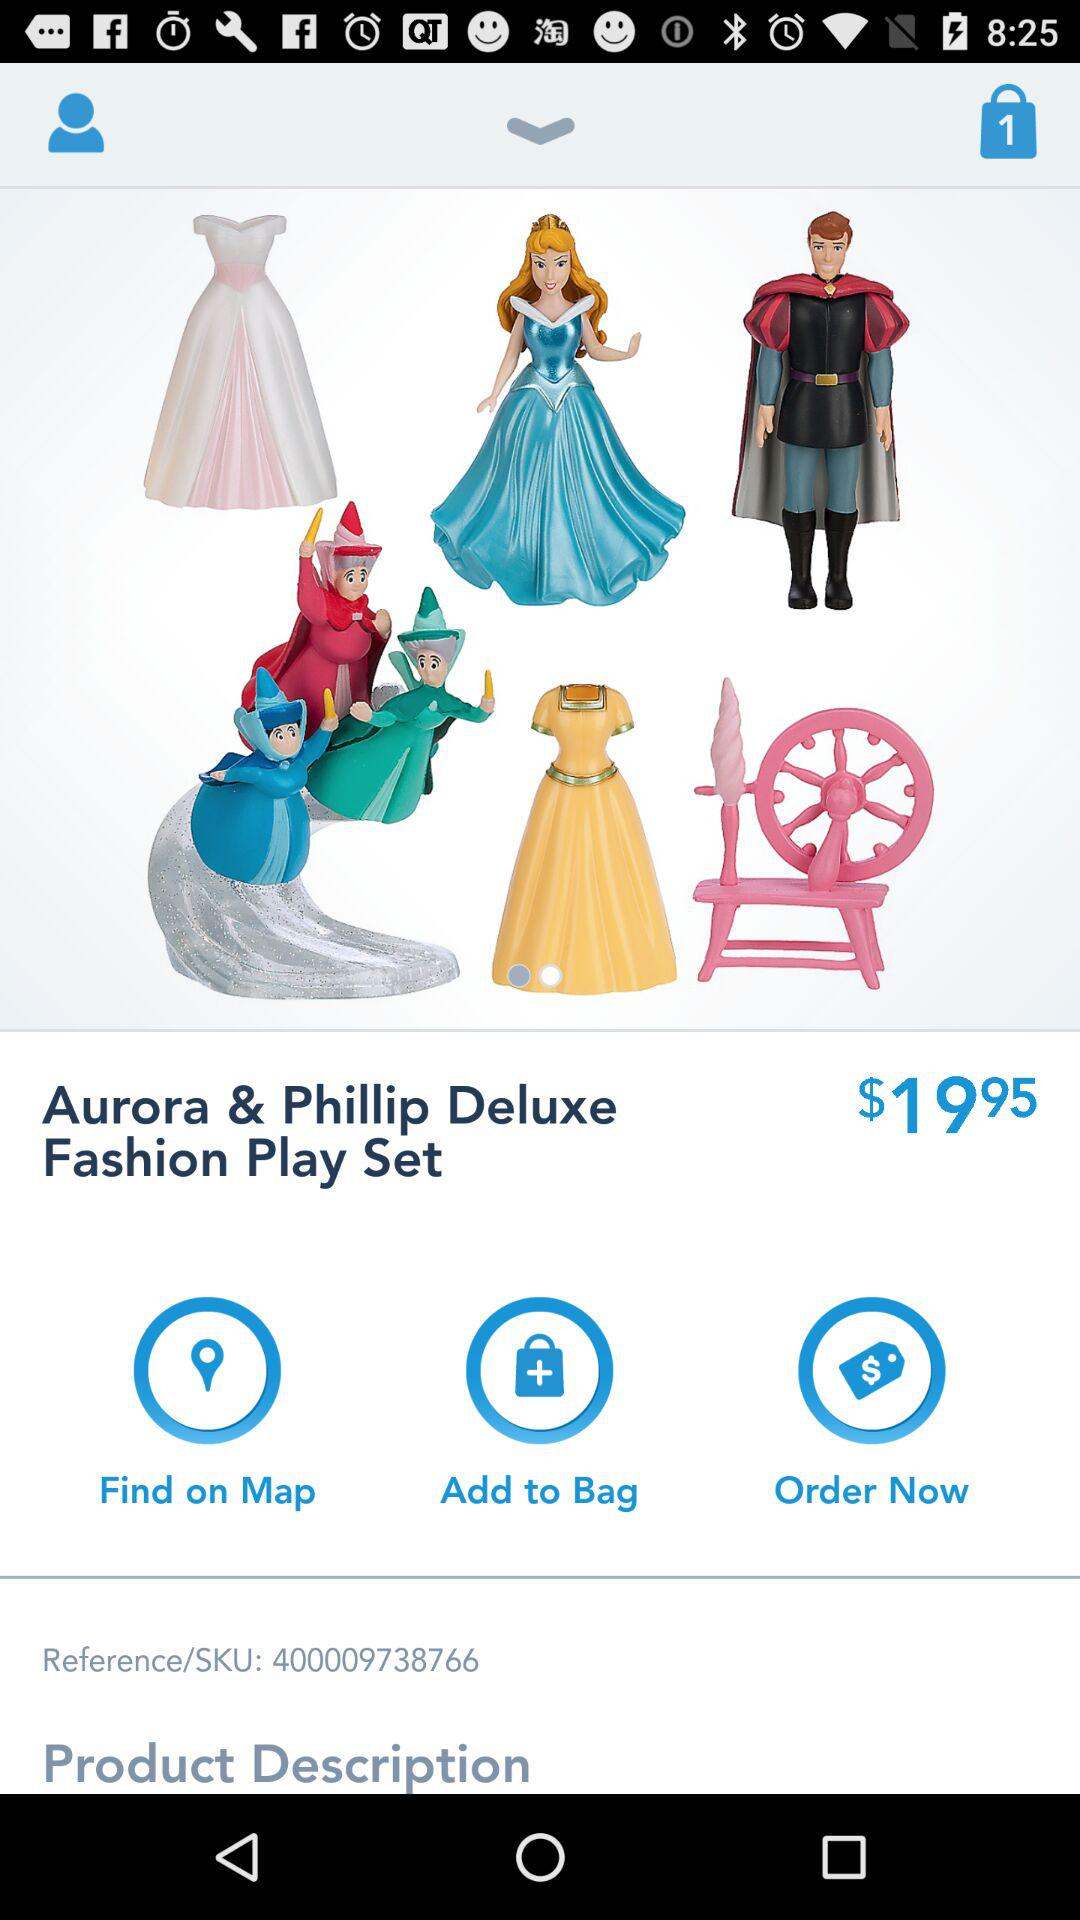What is the price of the product?
Answer the question using a single word or phrase. $19.95 